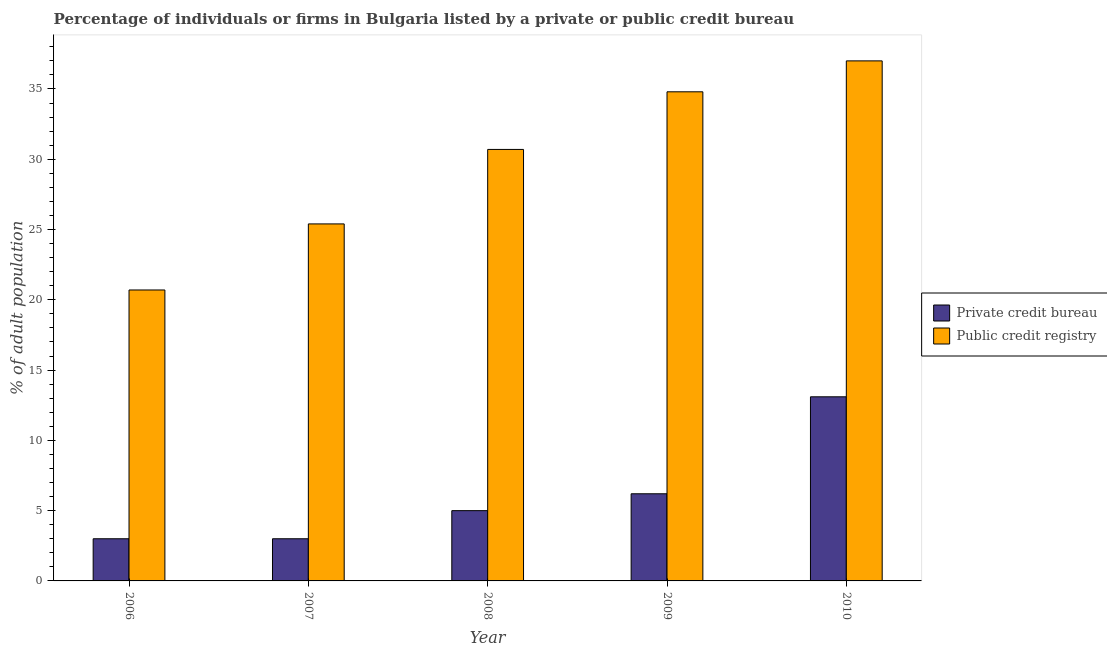How many different coloured bars are there?
Your answer should be compact. 2. How many bars are there on the 3rd tick from the left?
Make the answer very short. 2. How many bars are there on the 4th tick from the right?
Keep it short and to the point. 2. In how many cases, is the number of bars for a given year not equal to the number of legend labels?
Your answer should be very brief. 0. What is the percentage of firms listed by public credit bureau in 2008?
Provide a short and direct response. 30.7. Across all years, what is the maximum percentage of firms listed by private credit bureau?
Offer a terse response. 13.1. Across all years, what is the minimum percentage of firms listed by public credit bureau?
Provide a short and direct response. 20.7. In which year was the percentage of firms listed by public credit bureau minimum?
Your response must be concise. 2006. What is the total percentage of firms listed by private credit bureau in the graph?
Your response must be concise. 30.3. What is the difference between the percentage of firms listed by private credit bureau in 2009 and the percentage of firms listed by public credit bureau in 2008?
Give a very brief answer. 1.2. What is the average percentage of firms listed by public credit bureau per year?
Provide a short and direct response. 29.72. In the year 2006, what is the difference between the percentage of firms listed by public credit bureau and percentage of firms listed by private credit bureau?
Your answer should be very brief. 0. What is the ratio of the percentage of firms listed by public credit bureau in 2006 to that in 2007?
Give a very brief answer. 0.81. Is the percentage of firms listed by private credit bureau in 2006 less than that in 2009?
Provide a succinct answer. Yes. What is the difference between the highest and the second highest percentage of firms listed by public credit bureau?
Your answer should be compact. 2.2. What does the 1st bar from the left in 2006 represents?
Offer a terse response. Private credit bureau. What does the 1st bar from the right in 2009 represents?
Your answer should be compact. Public credit registry. How many bars are there?
Your answer should be compact. 10. How many years are there in the graph?
Give a very brief answer. 5. What is the difference between two consecutive major ticks on the Y-axis?
Give a very brief answer. 5. How many legend labels are there?
Your response must be concise. 2. How are the legend labels stacked?
Offer a terse response. Vertical. What is the title of the graph?
Keep it short and to the point. Percentage of individuals or firms in Bulgaria listed by a private or public credit bureau. What is the label or title of the X-axis?
Give a very brief answer. Year. What is the label or title of the Y-axis?
Ensure brevity in your answer.  % of adult population. What is the % of adult population of Public credit registry in 2006?
Provide a succinct answer. 20.7. What is the % of adult population in Private credit bureau in 2007?
Offer a terse response. 3. What is the % of adult population in Public credit registry in 2007?
Your response must be concise. 25.4. What is the % of adult population of Private credit bureau in 2008?
Your answer should be compact. 5. What is the % of adult population of Public credit registry in 2008?
Your answer should be compact. 30.7. What is the % of adult population in Private credit bureau in 2009?
Provide a short and direct response. 6.2. What is the % of adult population in Public credit registry in 2009?
Your answer should be very brief. 34.8. What is the % of adult population in Public credit registry in 2010?
Your answer should be very brief. 37. Across all years, what is the minimum % of adult population of Public credit registry?
Make the answer very short. 20.7. What is the total % of adult population of Private credit bureau in the graph?
Ensure brevity in your answer.  30.3. What is the total % of adult population in Public credit registry in the graph?
Your answer should be very brief. 148.6. What is the difference between the % of adult population of Private credit bureau in 2006 and that in 2007?
Your answer should be very brief. 0. What is the difference between the % of adult population of Public credit registry in 2006 and that in 2007?
Offer a terse response. -4.7. What is the difference between the % of adult population in Public credit registry in 2006 and that in 2008?
Give a very brief answer. -10. What is the difference between the % of adult population in Private credit bureau in 2006 and that in 2009?
Provide a short and direct response. -3.2. What is the difference between the % of adult population of Public credit registry in 2006 and that in 2009?
Your response must be concise. -14.1. What is the difference between the % of adult population in Private credit bureau in 2006 and that in 2010?
Your answer should be very brief. -10.1. What is the difference between the % of adult population in Public credit registry in 2006 and that in 2010?
Give a very brief answer. -16.3. What is the difference between the % of adult population in Public credit registry in 2007 and that in 2009?
Provide a succinct answer. -9.4. What is the difference between the % of adult population in Private credit bureau in 2007 and that in 2010?
Offer a very short reply. -10.1. What is the difference between the % of adult population of Public credit registry in 2007 and that in 2010?
Your answer should be compact. -11.6. What is the difference between the % of adult population in Private credit bureau in 2008 and that in 2009?
Keep it short and to the point. -1.2. What is the difference between the % of adult population in Private credit bureau in 2008 and that in 2010?
Your response must be concise. -8.1. What is the difference between the % of adult population in Private credit bureau in 2009 and that in 2010?
Your response must be concise. -6.9. What is the difference between the % of adult population in Public credit registry in 2009 and that in 2010?
Give a very brief answer. -2.2. What is the difference between the % of adult population in Private credit bureau in 2006 and the % of adult population in Public credit registry in 2007?
Offer a terse response. -22.4. What is the difference between the % of adult population of Private credit bureau in 2006 and the % of adult population of Public credit registry in 2008?
Provide a succinct answer. -27.7. What is the difference between the % of adult population in Private credit bureau in 2006 and the % of adult population in Public credit registry in 2009?
Provide a short and direct response. -31.8. What is the difference between the % of adult population of Private credit bureau in 2006 and the % of adult population of Public credit registry in 2010?
Your answer should be compact. -34. What is the difference between the % of adult population of Private credit bureau in 2007 and the % of adult population of Public credit registry in 2008?
Provide a short and direct response. -27.7. What is the difference between the % of adult population in Private credit bureau in 2007 and the % of adult population in Public credit registry in 2009?
Offer a terse response. -31.8. What is the difference between the % of adult population in Private credit bureau in 2007 and the % of adult population in Public credit registry in 2010?
Provide a succinct answer. -34. What is the difference between the % of adult population in Private credit bureau in 2008 and the % of adult population in Public credit registry in 2009?
Ensure brevity in your answer.  -29.8. What is the difference between the % of adult population in Private credit bureau in 2008 and the % of adult population in Public credit registry in 2010?
Your answer should be compact. -32. What is the difference between the % of adult population of Private credit bureau in 2009 and the % of adult population of Public credit registry in 2010?
Ensure brevity in your answer.  -30.8. What is the average % of adult population in Private credit bureau per year?
Provide a short and direct response. 6.06. What is the average % of adult population in Public credit registry per year?
Offer a terse response. 29.72. In the year 2006, what is the difference between the % of adult population of Private credit bureau and % of adult population of Public credit registry?
Provide a short and direct response. -17.7. In the year 2007, what is the difference between the % of adult population of Private credit bureau and % of adult population of Public credit registry?
Offer a very short reply. -22.4. In the year 2008, what is the difference between the % of adult population in Private credit bureau and % of adult population in Public credit registry?
Provide a succinct answer. -25.7. In the year 2009, what is the difference between the % of adult population of Private credit bureau and % of adult population of Public credit registry?
Keep it short and to the point. -28.6. In the year 2010, what is the difference between the % of adult population in Private credit bureau and % of adult population in Public credit registry?
Offer a terse response. -23.9. What is the ratio of the % of adult population in Public credit registry in 2006 to that in 2007?
Your answer should be compact. 0.81. What is the ratio of the % of adult population in Public credit registry in 2006 to that in 2008?
Offer a terse response. 0.67. What is the ratio of the % of adult population of Private credit bureau in 2006 to that in 2009?
Your response must be concise. 0.48. What is the ratio of the % of adult population in Public credit registry in 2006 to that in 2009?
Your answer should be very brief. 0.59. What is the ratio of the % of adult population of Private credit bureau in 2006 to that in 2010?
Make the answer very short. 0.23. What is the ratio of the % of adult population of Public credit registry in 2006 to that in 2010?
Provide a succinct answer. 0.56. What is the ratio of the % of adult population of Public credit registry in 2007 to that in 2008?
Provide a succinct answer. 0.83. What is the ratio of the % of adult population in Private credit bureau in 2007 to that in 2009?
Provide a short and direct response. 0.48. What is the ratio of the % of adult population in Public credit registry in 2007 to that in 2009?
Keep it short and to the point. 0.73. What is the ratio of the % of adult population in Private credit bureau in 2007 to that in 2010?
Provide a succinct answer. 0.23. What is the ratio of the % of adult population in Public credit registry in 2007 to that in 2010?
Your answer should be very brief. 0.69. What is the ratio of the % of adult population of Private credit bureau in 2008 to that in 2009?
Give a very brief answer. 0.81. What is the ratio of the % of adult population in Public credit registry in 2008 to that in 2009?
Your response must be concise. 0.88. What is the ratio of the % of adult population of Private credit bureau in 2008 to that in 2010?
Your response must be concise. 0.38. What is the ratio of the % of adult population of Public credit registry in 2008 to that in 2010?
Ensure brevity in your answer.  0.83. What is the ratio of the % of adult population of Private credit bureau in 2009 to that in 2010?
Keep it short and to the point. 0.47. What is the ratio of the % of adult population in Public credit registry in 2009 to that in 2010?
Give a very brief answer. 0.94. What is the difference between the highest and the lowest % of adult population of Private credit bureau?
Give a very brief answer. 10.1. What is the difference between the highest and the lowest % of adult population in Public credit registry?
Ensure brevity in your answer.  16.3. 